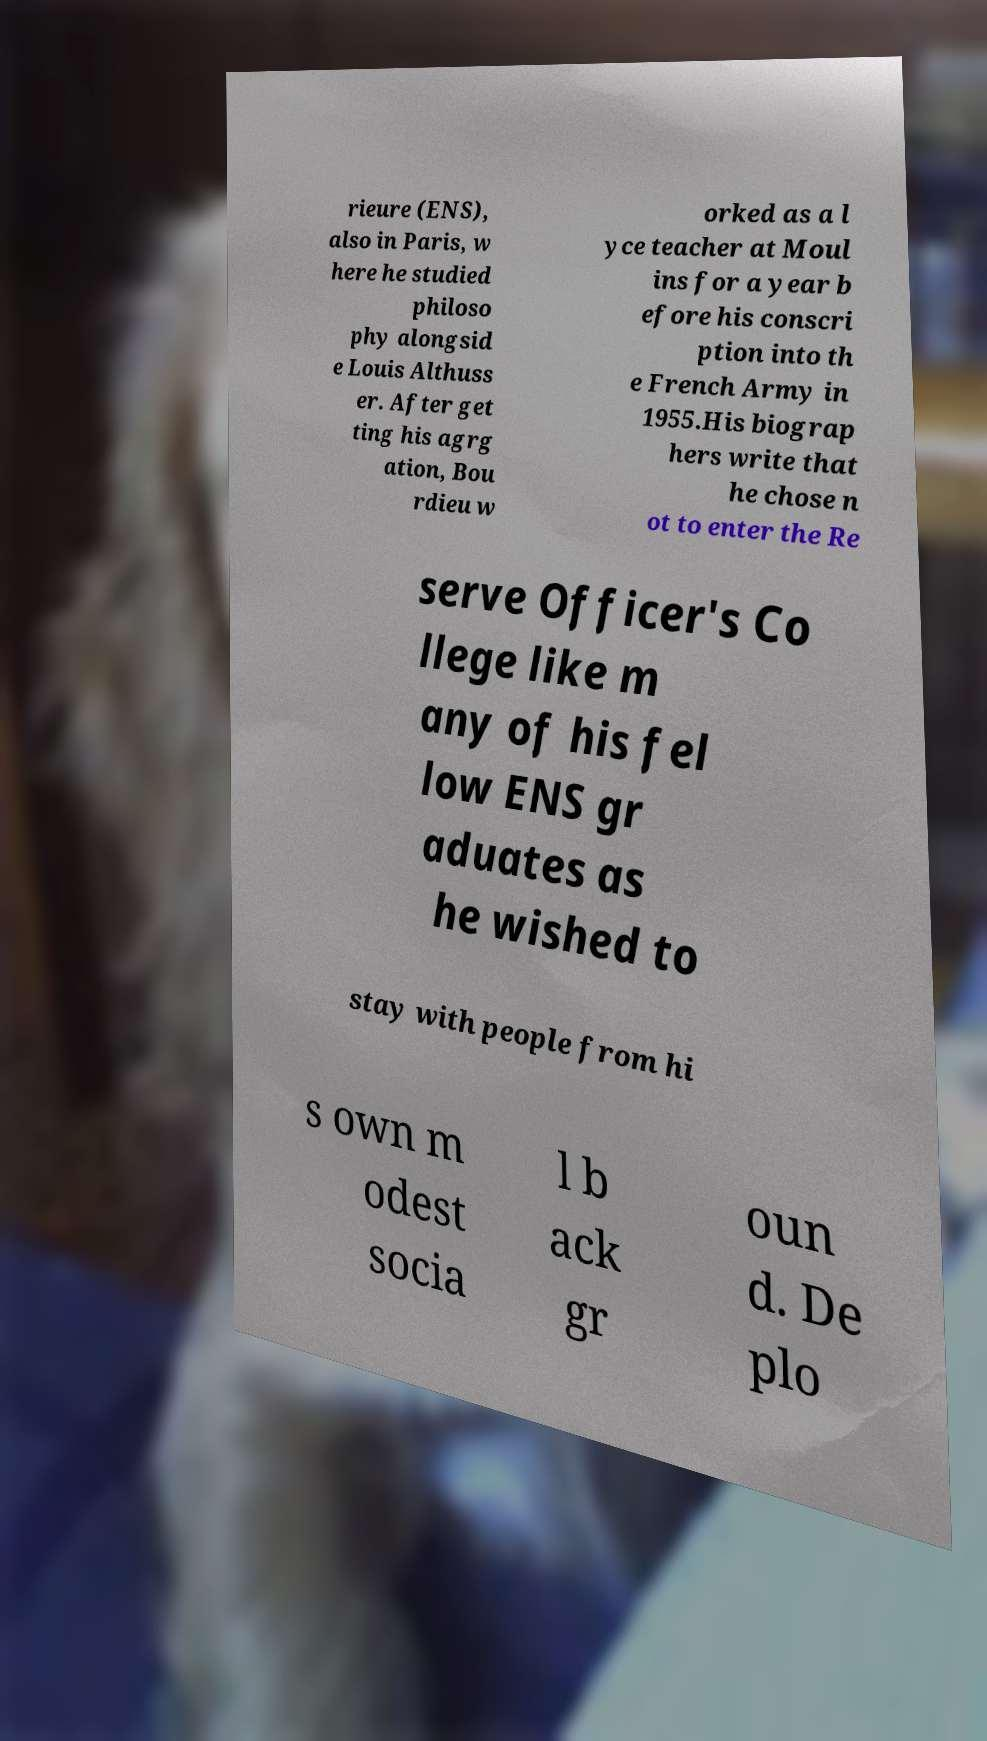Please identify and transcribe the text found in this image. rieure (ENS), also in Paris, w here he studied philoso phy alongsid e Louis Althuss er. After get ting his agrg ation, Bou rdieu w orked as a l yce teacher at Moul ins for a year b efore his conscri ption into th e French Army in 1955.His biograp hers write that he chose n ot to enter the Re serve Officer's Co llege like m any of his fel low ENS gr aduates as he wished to stay with people from hi s own m odest socia l b ack gr oun d. De plo 